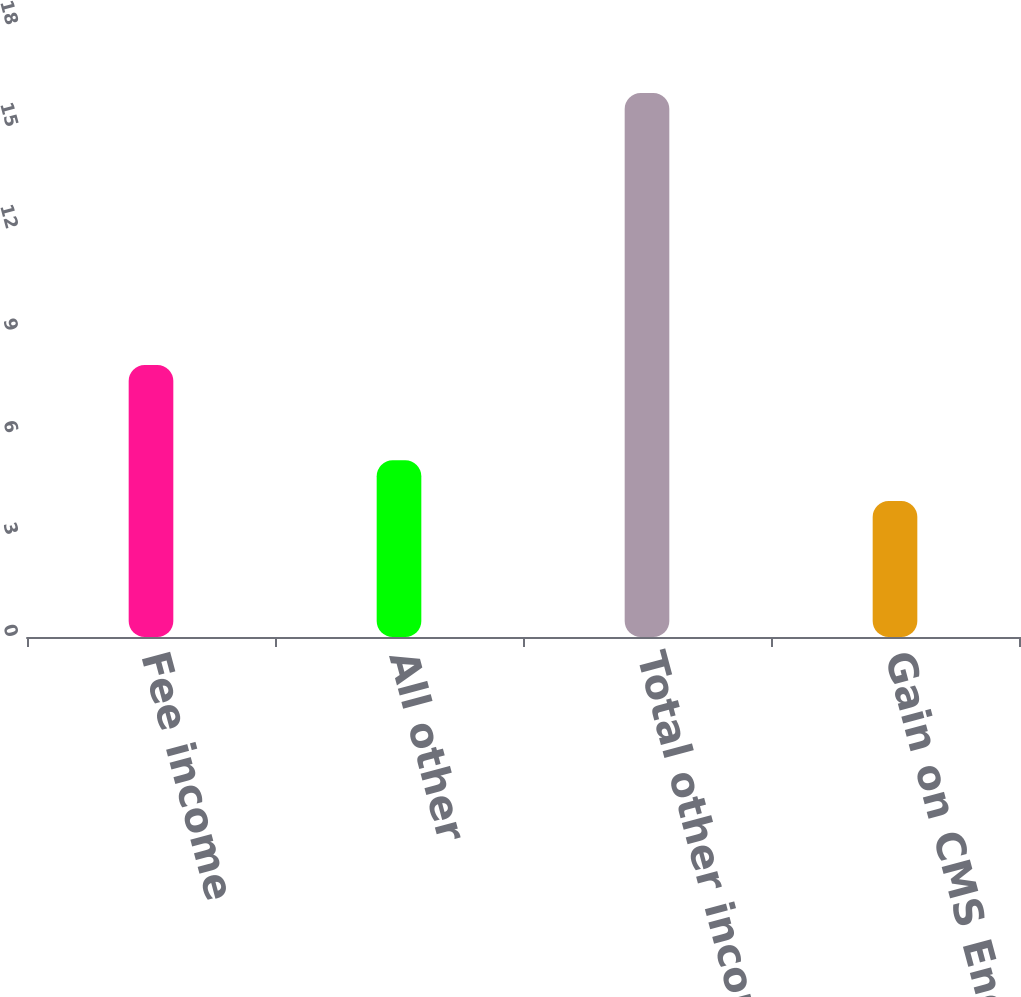Convert chart. <chart><loc_0><loc_0><loc_500><loc_500><bar_chart><fcel>Fee income<fcel>All other<fcel>Total other income<fcel>Gain on CMS Energy common<nl><fcel>8<fcel>5.2<fcel>16<fcel>4<nl></chart> 